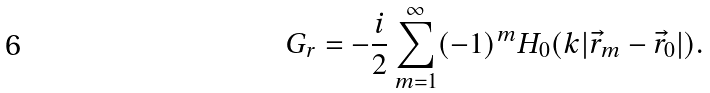<formula> <loc_0><loc_0><loc_500><loc_500>G _ { r } = - \frac { i } { 2 } \sum _ { m = 1 } ^ { \infty } ( - 1 ) ^ { m } H _ { 0 } ( k | \vec { r } _ { m } - \vec { r } _ { 0 } | ) .</formula> 